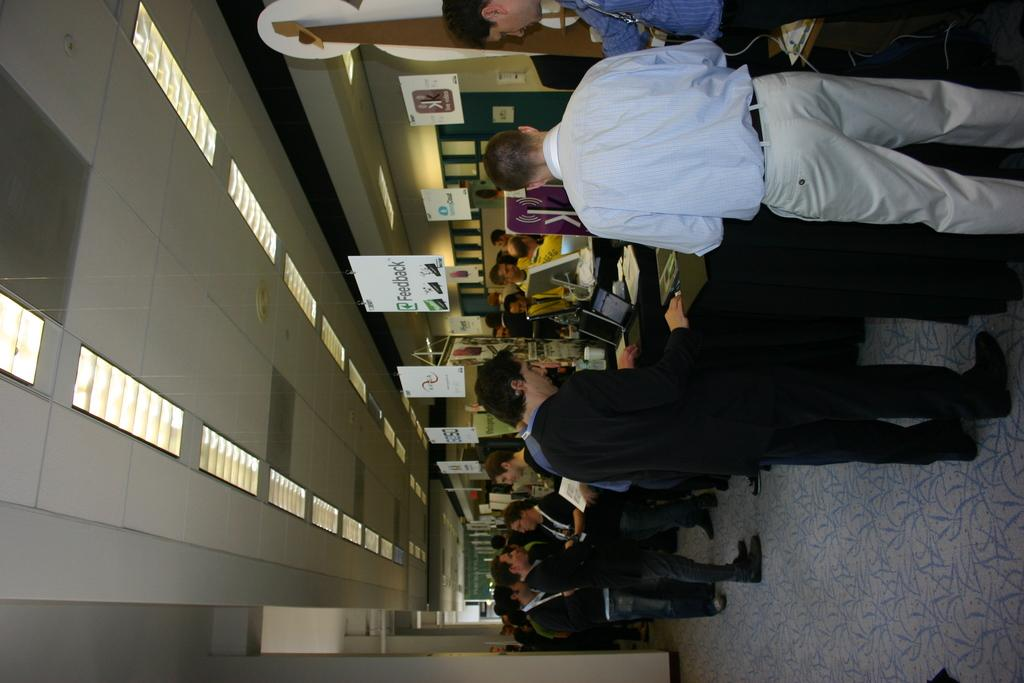What type of electronic devices can be seen in the image? There are laptops in the image. What else is present on the surfaces in the image? There are papers and wires visible in the image. What type of decorations are on the walls in the image? There are posters in the image. What type of lighting is present in the image? There are lights in the image. What can be seen on the floor in the image? There is a group of people standing on the floor in the image. What architectural features are visible in the background of the image? There are pillars in the background of the image. What type of punishment is being carried out in the image? There is no indication of punishment in the image; it features laptops, papers, wires, posters, lights, a group of people, and pillars. What country is depicted in the image? The image does not depict a specific country; it shows a group of people in a room with laptops, papers, wires, posters, lights, and pillars. 